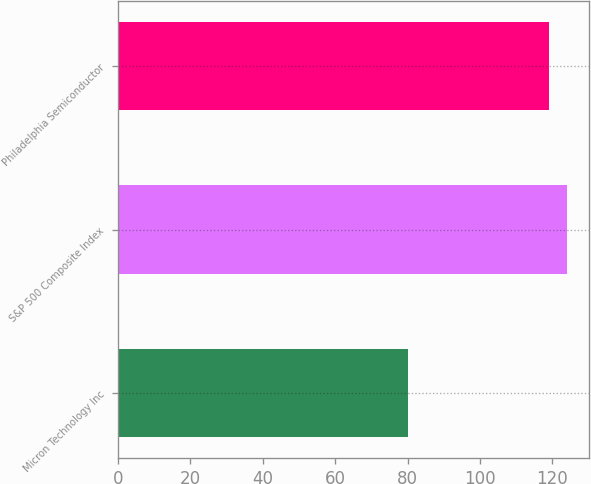<chart> <loc_0><loc_0><loc_500><loc_500><bar_chart><fcel>Micron Technology Inc<fcel>S&P 500 Composite Index<fcel>Philadelphia Semiconductor<nl><fcel>80<fcel>124<fcel>119<nl></chart> 